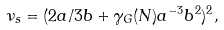Convert formula to latex. <formula><loc_0><loc_0><loc_500><loc_500>\nu _ { s } = ( 2 a / 3 b + \gamma _ { G } ( N ) a ^ { - 3 } b ^ { 2 } ) ^ { 2 } ,</formula> 